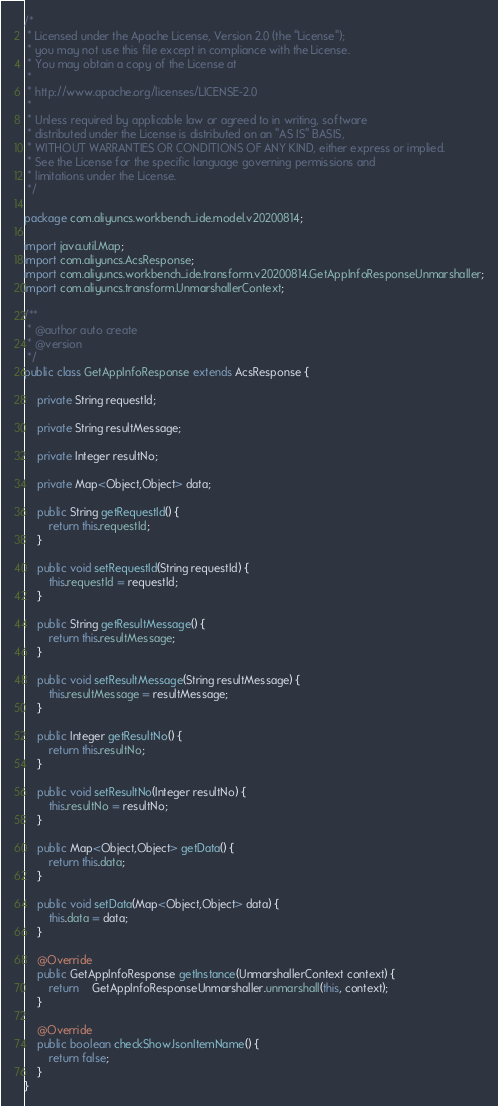Convert code to text. <code><loc_0><loc_0><loc_500><loc_500><_Java_>/*
 * Licensed under the Apache License, Version 2.0 (the "License");
 * you may not use this file except in compliance with the License.
 * You may obtain a copy of the License at
 *
 * http://www.apache.org/licenses/LICENSE-2.0
 *
 * Unless required by applicable law or agreed to in writing, software
 * distributed under the License is distributed on an "AS IS" BASIS,
 * WITHOUT WARRANTIES OR CONDITIONS OF ANY KIND, either express or implied.
 * See the License for the specific language governing permissions and
 * limitations under the License.
 */

package com.aliyuncs.workbench_ide.model.v20200814;

import java.util.Map;
import com.aliyuncs.AcsResponse;
import com.aliyuncs.workbench_ide.transform.v20200814.GetAppInfoResponseUnmarshaller;
import com.aliyuncs.transform.UnmarshallerContext;

/**
 * @author auto create
 * @version 
 */
public class GetAppInfoResponse extends AcsResponse {

	private String requestId;

	private String resultMessage;

	private Integer resultNo;

	private Map<Object,Object> data;

	public String getRequestId() {
		return this.requestId;
	}

	public void setRequestId(String requestId) {
		this.requestId = requestId;
	}

	public String getResultMessage() {
		return this.resultMessage;
	}

	public void setResultMessage(String resultMessage) {
		this.resultMessage = resultMessage;
	}

	public Integer getResultNo() {
		return this.resultNo;
	}

	public void setResultNo(Integer resultNo) {
		this.resultNo = resultNo;
	}

	public Map<Object,Object> getData() {
		return this.data;
	}

	public void setData(Map<Object,Object> data) {
		this.data = data;
	}

	@Override
	public GetAppInfoResponse getInstance(UnmarshallerContext context) {
		return	GetAppInfoResponseUnmarshaller.unmarshall(this, context);
	}

	@Override
	public boolean checkShowJsonItemName() {
		return false;
	}
}
</code> 